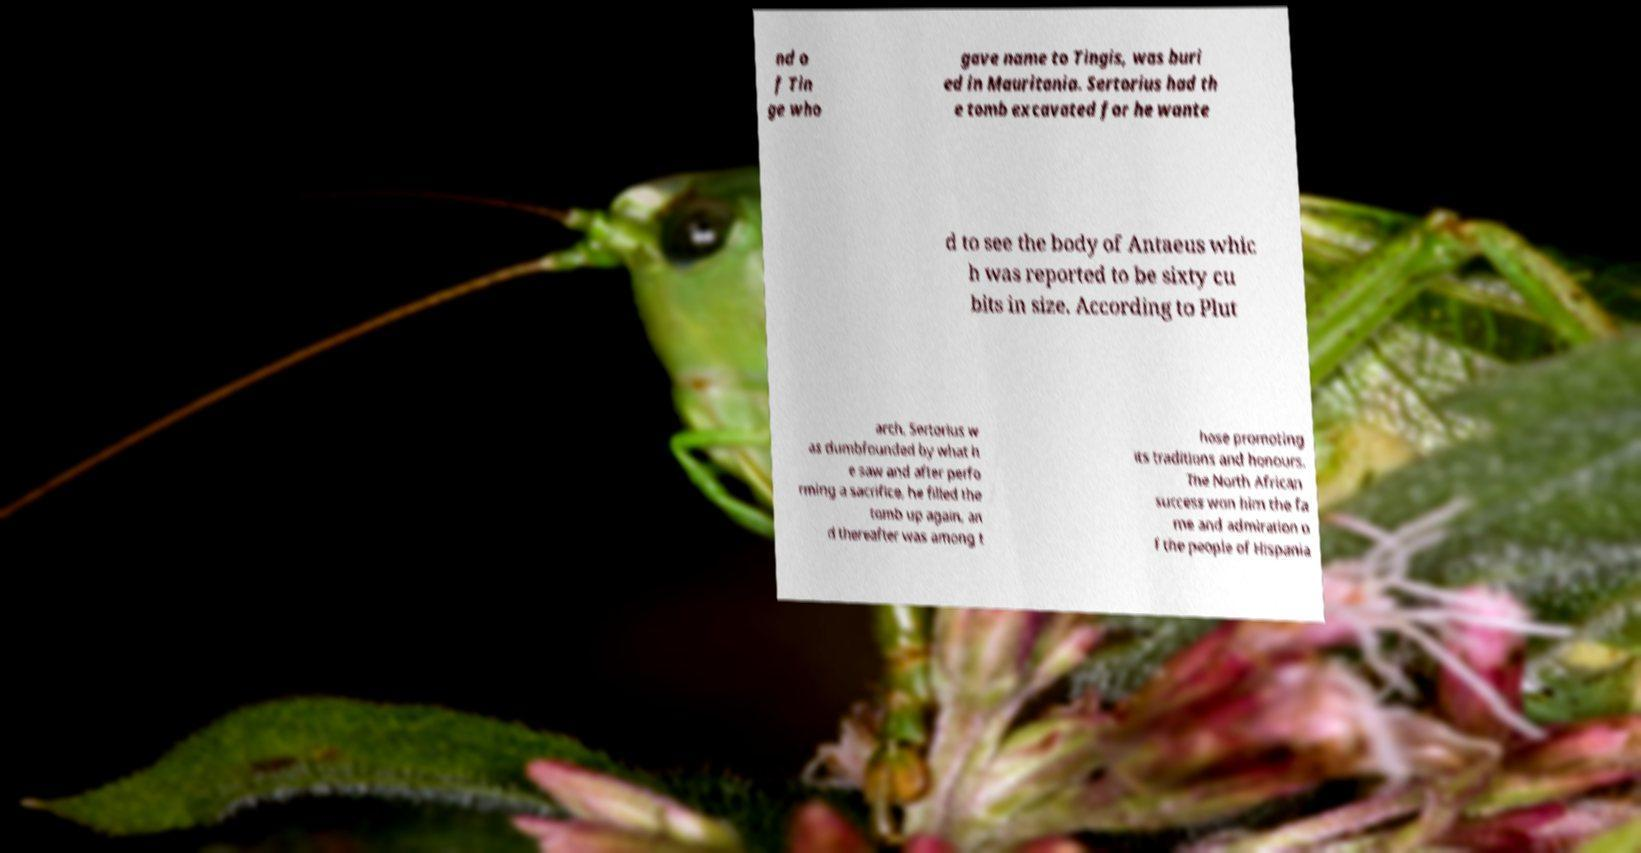There's text embedded in this image that I need extracted. Can you transcribe it verbatim? nd o f Tin ge who gave name to Tingis, was buri ed in Mauritania. Sertorius had th e tomb excavated for he wante d to see the body of Antaeus whic h was reported to be sixty cu bits in size. According to Plut arch, Sertorius w as dumbfounded by what h e saw and after perfo rming a sacrifice, he filled the tomb up again, an d thereafter was among t hose promoting its traditions and honours. The North African success won him the fa me and admiration o f the people of Hispania 